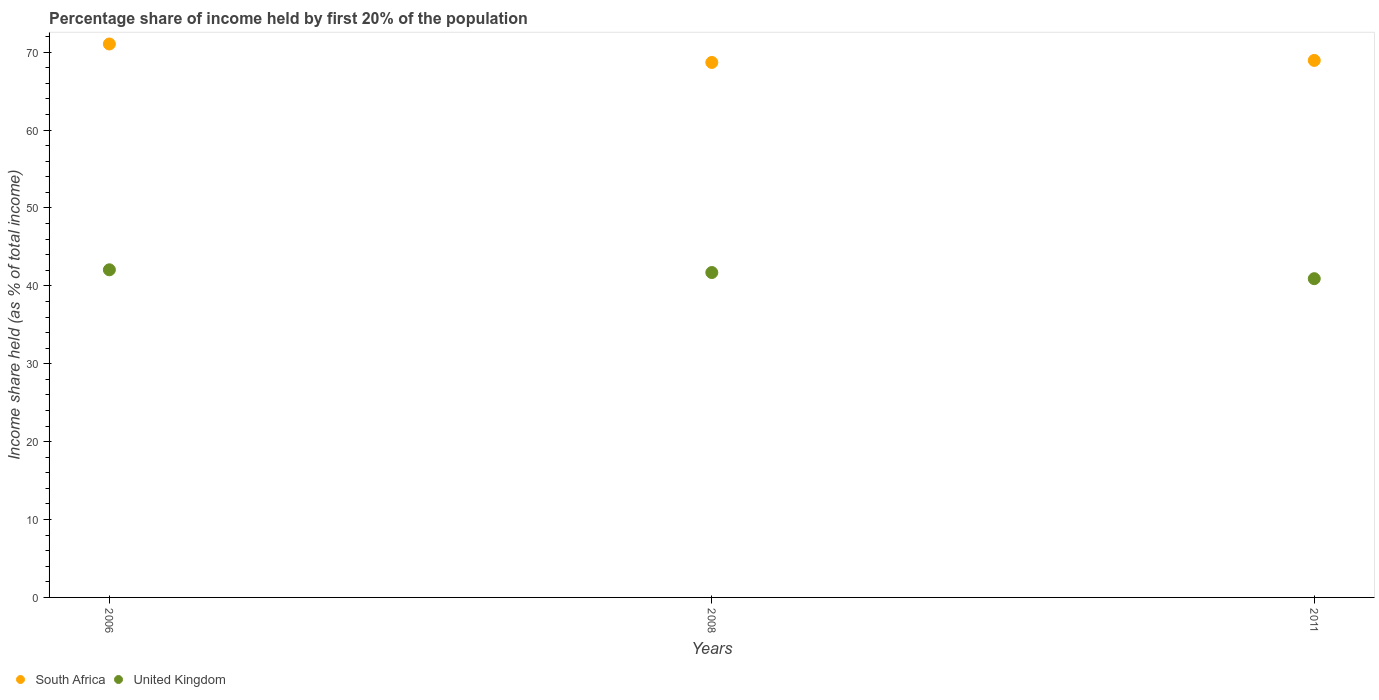Is the number of dotlines equal to the number of legend labels?
Provide a short and direct response. Yes. What is the share of income held by first 20% of the population in United Kingdom in 2011?
Provide a succinct answer. 40.92. Across all years, what is the maximum share of income held by first 20% of the population in South Africa?
Make the answer very short. 71.05. Across all years, what is the minimum share of income held by first 20% of the population in South Africa?
Your answer should be very brief. 68.68. In which year was the share of income held by first 20% of the population in South Africa minimum?
Your answer should be very brief. 2008. What is the total share of income held by first 20% of the population in United Kingdom in the graph?
Provide a succinct answer. 124.69. What is the difference between the share of income held by first 20% of the population in South Africa in 2006 and that in 2008?
Your answer should be compact. 2.37. What is the difference between the share of income held by first 20% of the population in South Africa in 2011 and the share of income held by first 20% of the population in United Kingdom in 2008?
Offer a very short reply. 27.23. What is the average share of income held by first 20% of the population in South Africa per year?
Make the answer very short. 69.56. In the year 2011, what is the difference between the share of income held by first 20% of the population in South Africa and share of income held by first 20% of the population in United Kingdom?
Keep it short and to the point. 28.02. What is the ratio of the share of income held by first 20% of the population in South Africa in 2006 to that in 2011?
Your response must be concise. 1.03. Is the difference between the share of income held by first 20% of the population in South Africa in 2006 and 2008 greater than the difference between the share of income held by first 20% of the population in United Kingdom in 2006 and 2008?
Your response must be concise. Yes. What is the difference between the highest and the second highest share of income held by first 20% of the population in South Africa?
Make the answer very short. 2.11. What is the difference between the highest and the lowest share of income held by first 20% of the population in United Kingdom?
Ensure brevity in your answer.  1.14. In how many years, is the share of income held by first 20% of the population in South Africa greater than the average share of income held by first 20% of the population in South Africa taken over all years?
Offer a very short reply. 1. Is the sum of the share of income held by first 20% of the population in South Africa in 2006 and 2008 greater than the maximum share of income held by first 20% of the population in United Kingdom across all years?
Your response must be concise. Yes. Does the share of income held by first 20% of the population in United Kingdom monotonically increase over the years?
Keep it short and to the point. No. Are the values on the major ticks of Y-axis written in scientific E-notation?
Your answer should be compact. No. Does the graph contain grids?
Your answer should be very brief. No. How many legend labels are there?
Keep it short and to the point. 2. What is the title of the graph?
Provide a short and direct response. Percentage share of income held by first 20% of the population. What is the label or title of the Y-axis?
Provide a succinct answer. Income share held (as % of total income). What is the Income share held (as % of total income) of South Africa in 2006?
Ensure brevity in your answer.  71.05. What is the Income share held (as % of total income) of United Kingdom in 2006?
Your answer should be compact. 42.06. What is the Income share held (as % of total income) of South Africa in 2008?
Give a very brief answer. 68.68. What is the Income share held (as % of total income) in United Kingdom in 2008?
Ensure brevity in your answer.  41.71. What is the Income share held (as % of total income) in South Africa in 2011?
Your answer should be very brief. 68.94. What is the Income share held (as % of total income) in United Kingdom in 2011?
Provide a succinct answer. 40.92. Across all years, what is the maximum Income share held (as % of total income) of South Africa?
Offer a terse response. 71.05. Across all years, what is the maximum Income share held (as % of total income) in United Kingdom?
Ensure brevity in your answer.  42.06. Across all years, what is the minimum Income share held (as % of total income) in South Africa?
Provide a short and direct response. 68.68. Across all years, what is the minimum Income share held (as % of total income) of United Kingdom?
Give a very brief answer. 40.92. What is the total Income share held (as % of total income) of South Africa in the graph?
Your answer should be compact. 208.67. What is the total Income share held (as % of total income) of United Kingdom in the graph?
Provide a short and direct response. 124.69. What is the difference between the Income share held (as % of total income) in South Africa in 2006 and that in 2008?
Provide a succinct answer. 2.37. What is the difference between the Income share held (as % of total income) of United Kingdom in 2006 and that in 2008?
Your response must be concise. 0.35. What is the difference between the Income share held (as % of total income) in South Africa in 2006 and that in 2011?
Make the answer very short. 2.11. What is the difference between the Income share held (as % of total income) of United Kingdom in 2006 and that in 2011?
Make the answer very short. 1.14. What is the difference between the Income share held (as % of total income) in South Africa in 2008 and that in 2011?
Provide a succinct answer. -0.26. What is the difference between the Income share held (as % of total income) in United Kingdom in 2008 and that in 2011?
Ensure brevity in your answer.  0.79. What is the difference between the Income share held (as % of total income) of South Africa in 2006 and the Income share held (as % of total income) of United Kingdom in 2008?
Your response must be concise. 29.34. What is the difference between the Income share held (as % of total income) of South Africa in 2006 and the Income share held (as % of total income) of United Kingdom in 2011?
Provide a succinct answer. 30.13. What is the difference between the Income share held (as % of total income) in South Africa in 2008 and the Income share held (as % of total income) in United Kingdom in 2011?
Your answer should be very brief. 27.76. What is the average Income share held (as % of total income) of South Africa per year?
Keep it short and to the point. 69.56. What is the average Income share held (as % of total income) in United Kingdom per year?
Keep it short and to the point. 41.56. In the year 2006, what is the difference between the Income share held (as % of total income) in South Africa and Income share held (as % of total income) in United Kingdom?
Keep it short and to the point. 28.99. In the year 2008, what is the difference between the Income share held (as % of total income) of South Africa and Income share held (as % of total income) of United Kingdom?
Provide a succinct answer. 26.97. In the year 2011, what is the difference between the Income share held (as % of total income) in South Africa and Income share held (as % of total income) in United Kingdom?
Your answer should be compact. 28.02. What is the ratio of the Income share held (as % of total income) of South Africa in 2006 to that in 2008?
Provide a succinct answer. 1.03. What is the ratio of the Income share held (as % of total income) of United Kingdom in 2006 to that in 2008?
Give a very brief answer. 1.01. What is the ratio of the Income share held (as % of total income) of South Africa in 2006 to that in 2011?
Offer a very short reply. 1.03. What is the ratio of the Income share held (as % of total income) in United Kingdom in 2006 to that in 2011?
Your answer should be compact. 1.03. What is the ratio of the Income share held (as % of total income) of United Kingdom in 2008 to that in 2011?
Offer a very short reply. 1.02. What is the difference between the highest and the second highest Income share held (as % of total income) in South Africa?
Offer a very short reply. 2.11. What is the difference between the highest and the lowest Income share held (as % of total income) in South Africa?
Make the answer very short. 2.37. What is the difference between the highest and the lowest Income share held (as % of total income) in United Kingdom?
Your response must be concise. 1.14. 